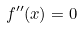Convert formula to latex. <formula><loc_0><loc_0><loc_500><loc_500>f ^ { \prime \prime } ( x ) = 0</formula> 